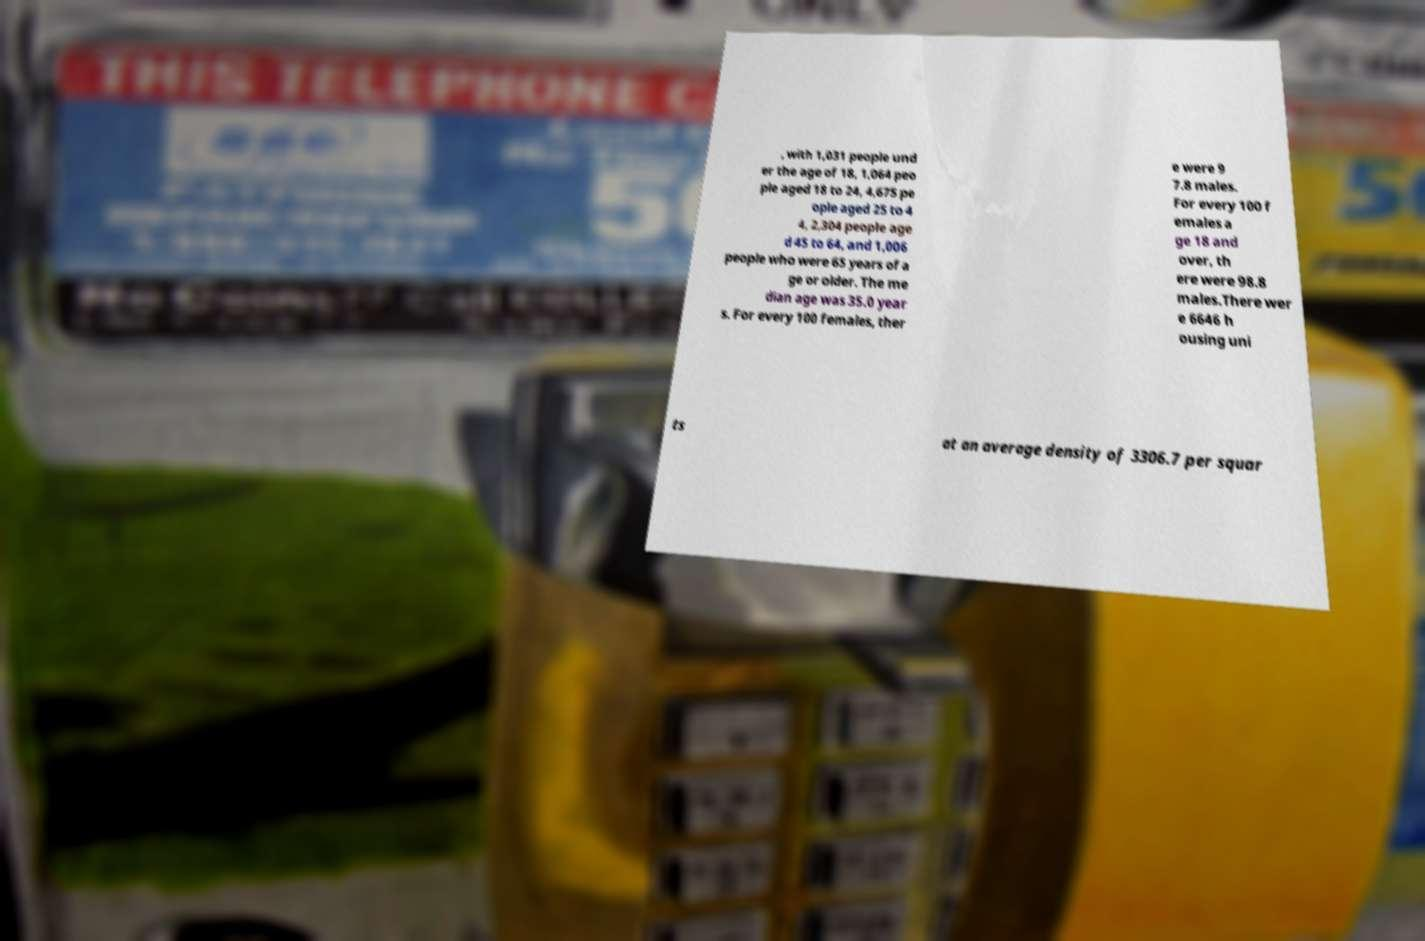Please read and relay the text visible in this image. What does it say? , with 1,031 people und er the age of 18, 1,064 peo ple aged 18 to 24, 4,675 pe ople aged 25 to 4 4, 2,304 people age d 45 to 64, and 1,006 people who were 65 years of a ge or older. The me dian age was 35.0 year s. For every 100 females, ther e were 9 7.8 males. For every 100 f emales a ge 18 and over, th ere were 98.8 males.There wer e 6646 h ousing uni ts at an average density of 3306.7 per squar 